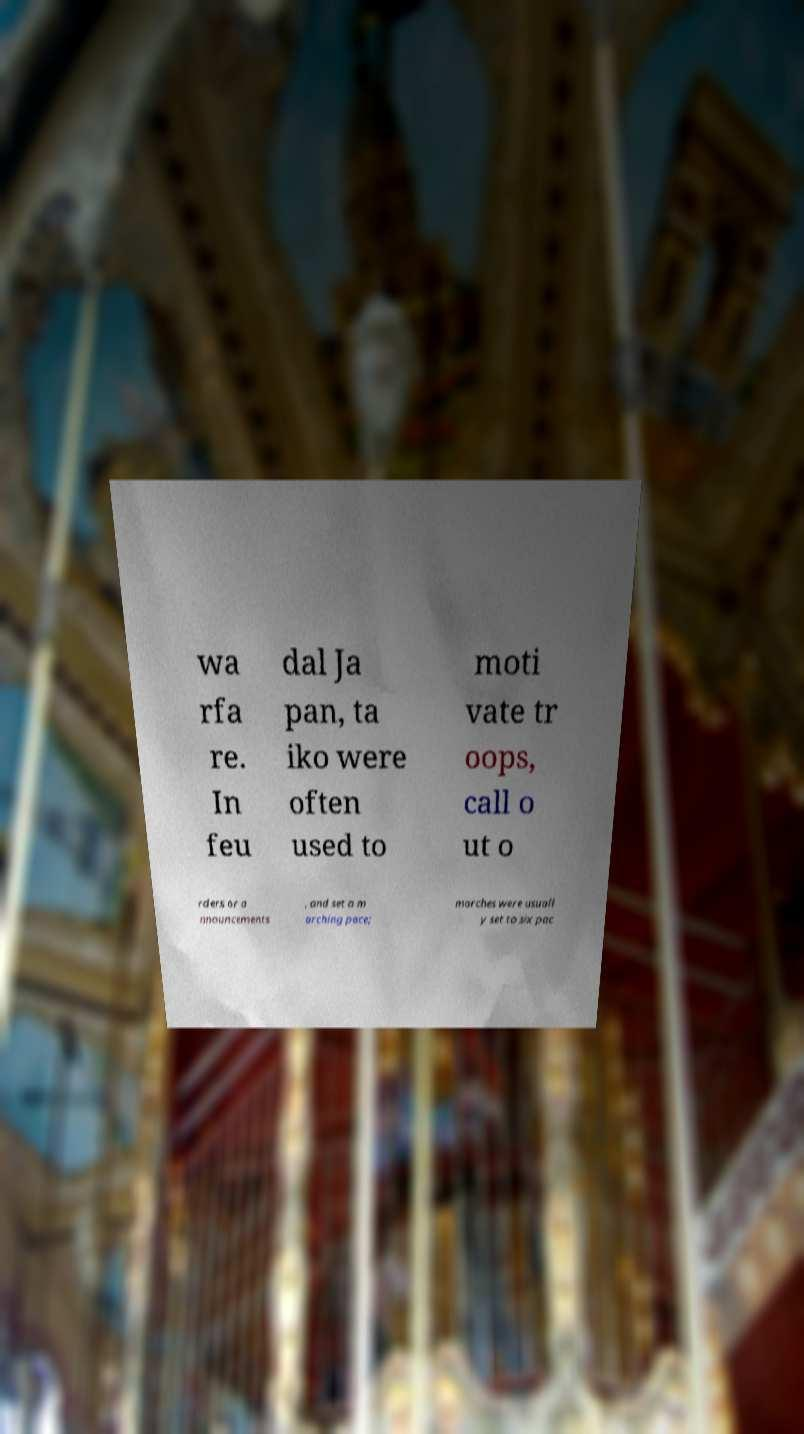Could you assist in decoding the text presented in this image and type it out clearly? wa rfa re. In feu dal Ja pan, ta iko were often used to moti vate tr oops, call o ut o rders or a nnouncements , and set a m arching pace; marches were usuall y set to six pac 